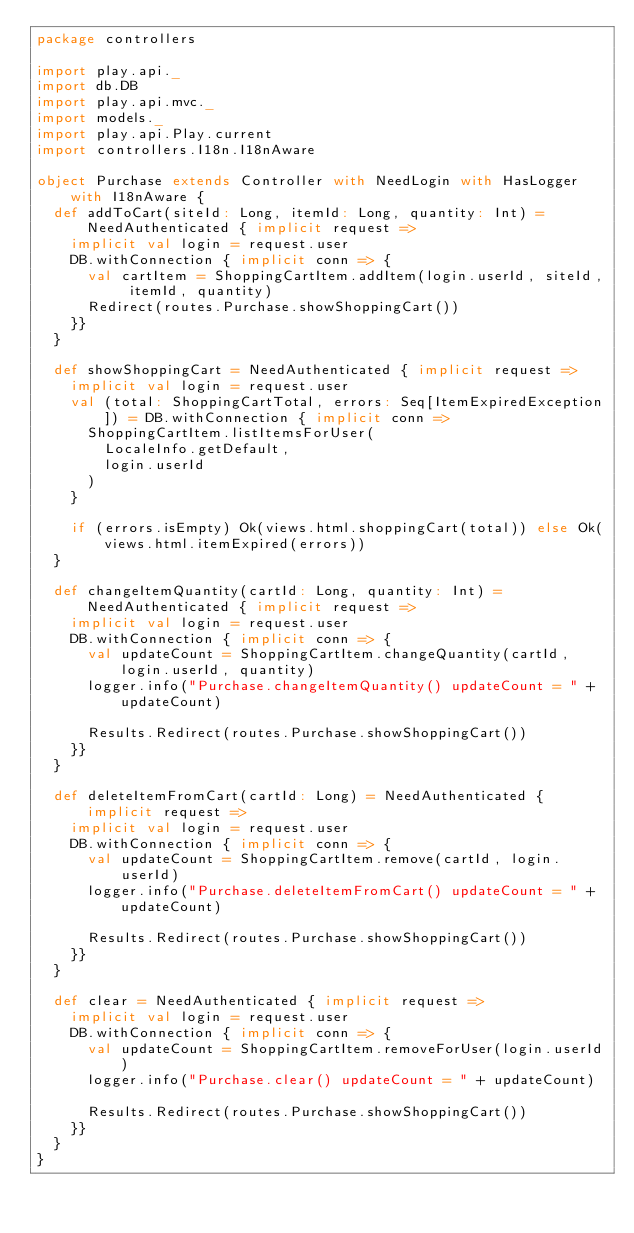<code> <loc_0><loc_0><loc_500><loc_500><_Scala_>package controllers

import play.api._
import db.DB
import play.api.mvc._
import models._
import play.api.Play.current
import controllers.I18n.I18nAware

object Purchase extends Controller with NeedLogin with HasLogger with I18nAware {
  def addToCart(siteId: Long, itemId: Long, quantity: Int) = NeedAuthenticated { implicit request =>
    implicit val login = request.user
    DB.withConnection { implicit conn => {
      val cartItem = ShoppingCartItem.addItem(login.userId, siteId, itemId, quantity)
      Redirect(routes.Purchase.showShoppingCart())
    }}
  }

  def showShoppingCart = NeedAuthenticated { implicit request =>
    implicit val login = request.user
    val (total: ShoppingCartTotal, errors: Seq[ItemExpiredException]) = DB.withConnection { implicit conn =>
      ShoppingCartItem.listItemsForUser(
        LocaleInfo.getDefault,
        login.userId
      )
    }

    if (errors.isEmpty) Ok(views.html.shoppingCart(total)) else Ok(views.html.itemExpired(errors))
  }

  def changeItemQuantity(cartId: Long, quantity: Int) = NeedAuthenticated { implicit request =>
    implicit val login = request.user
    DB.withConnection { implicit conn => {
      val updateCount = ShoppingCartItem.changeQuantity(cartId, login.userId, quantity)
      logger.info("Purchase.changeItemQuantity() updateCount = " + updateCount)

      Results.Redirect(routes.Purchase.showShoppingCart())
    }}
  }

  def deleteItemFromCart(cartId: Long) = NeedAuthenticated { implicit request =>
    implicit val login = request.user
    DB.withConnection { implicit conn => {
      val updateCount = ShoppingCartItem.remove(cartId, login.userId)
      logger.info("Purchase.deleteItemFromCart() updateCount = " + updateCount)

      Results.Redirect(routes.Purchase.showShoppingCart())
    }}
  }

  def clear = NeedAuthenticated { implicit request =>
    implicit val login = request.user
    DB.withConnection { implicit conn => {
      val updateCount = ShoppingCartItem.removeForUser(login.userId)
      logger.info("Purchase.clear() updateCount = " + updateCount)

      Results.Redirect(routes.Purchase.showShoppingCart())
    }}
  }
}
</code> 